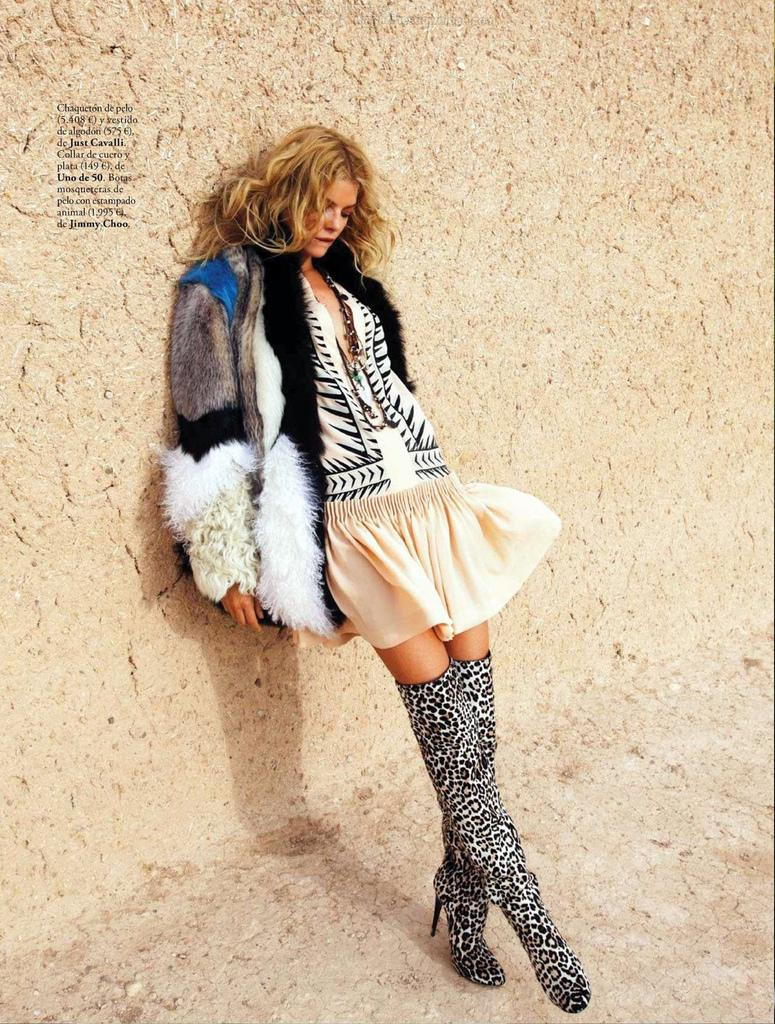Who or what is present in the image? There is a person in the image. What can be seen in the background of the image? There is a wall in the background of the image. Is there any additional information about the image itself? Yes, there is a watermark on the image. What type of yoke is being used by the person in the image? There is no yoke present in the image; it features a person and a wall in the background. 